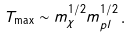Convert formula to latex. <formula><loc_0><loc_0><loc_500><loc_500>T _ { \max } \sim m _ { \chi } ^ { 1 / 2 } m _ { p l } ^ { 1 / 2 } \, .</formula> 